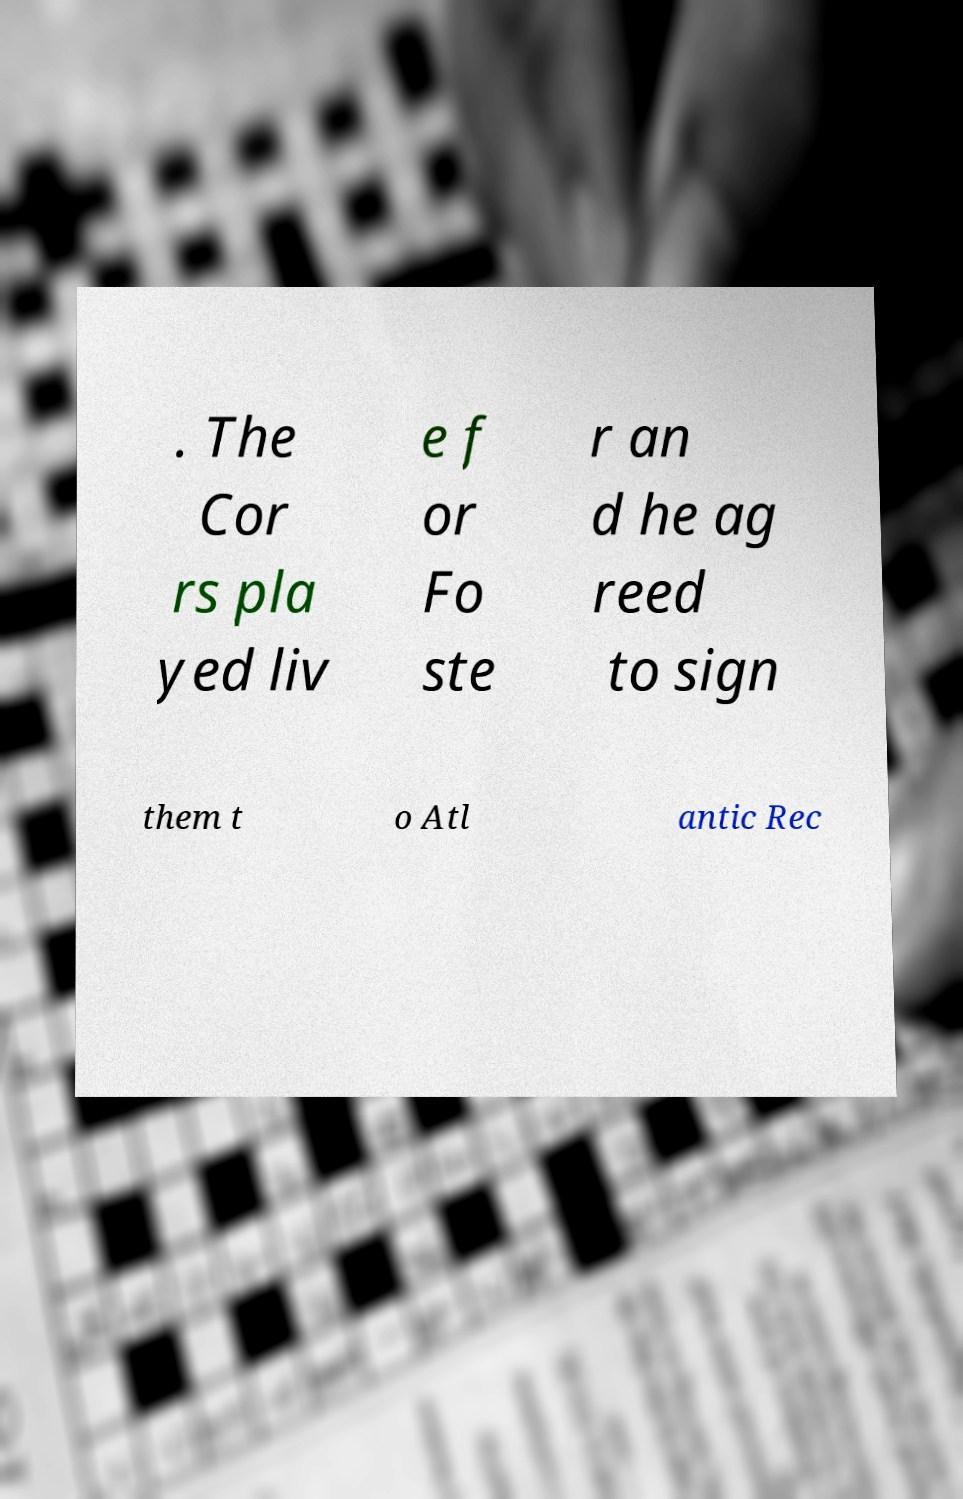Could you assist in decoding the text presented in this image and type it out clearly? . The Cor rs pla yed liv e f or Fo ste r an d he ag reed to sign them t o Atl antic Rec 